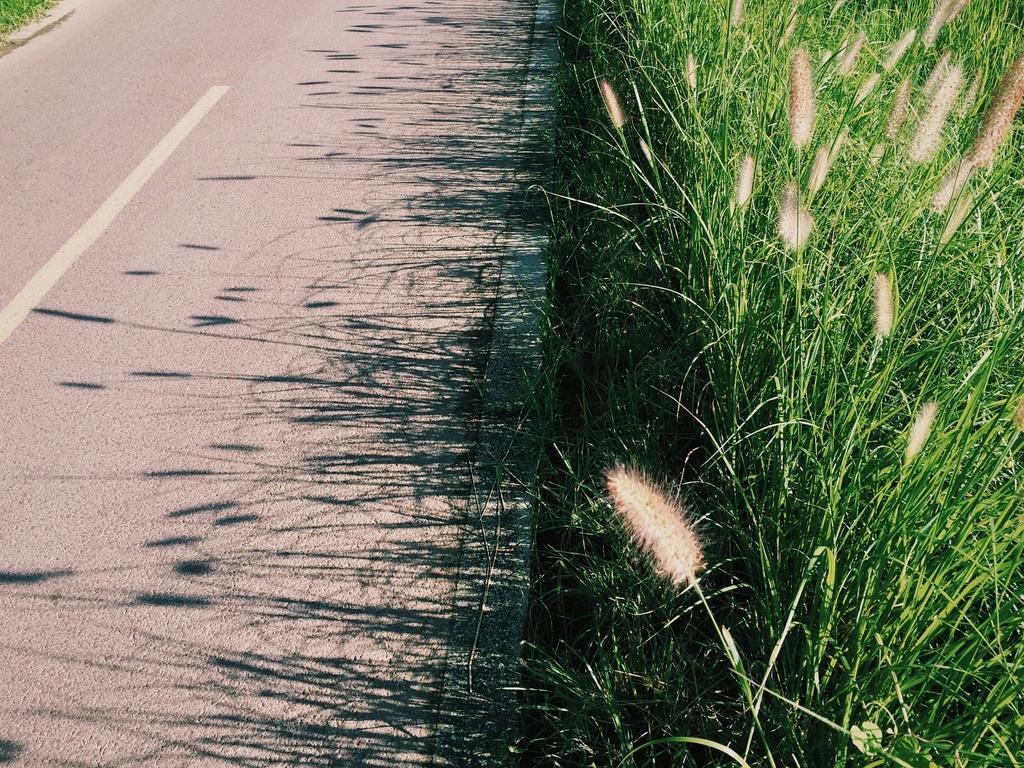Can you describe this image briefly? In this image there is a road and on the right side there is a green color grass. 